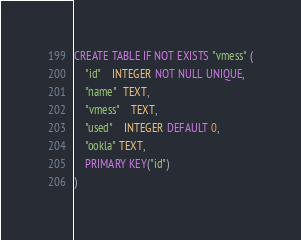Convert code to text. <code><loc_0><loc_0><loc_500><loc_500><_SQL_>CREATE TABLE IF NOT EXISTS "vmess" (
	"id"	INTEGER NOT NULL UNIQUE,
    "name"  TEXT,
	"vmess"	TEXT,
	"used"	INTEGER DEFAULT 0,
    "ookla" TEXT,
	PRIMARY KEY("id")
) </code> 